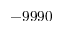Convert formula to latex. <formula><loc_0><loc_0><loc_500><loc_500>- 9 9 9 0</formula> 